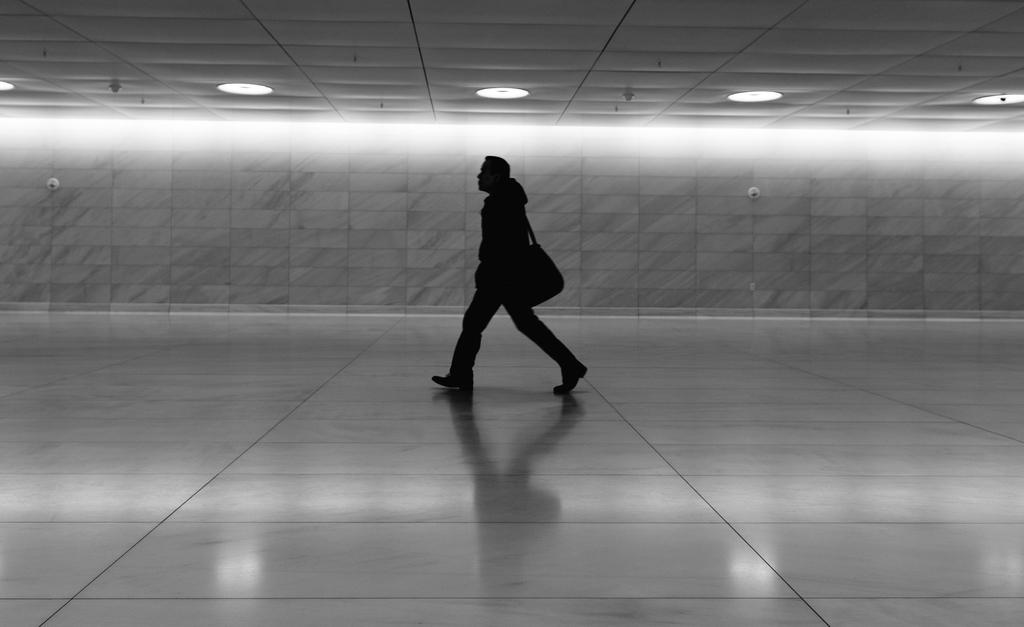Who is present in the image? There is a man in the image. What is the man doing in the image? The man is walking. What is the man carrying in the image? The man is wearing a bag. What can be seen in the background of the image? There is a wall in the background of the image. What is visible at the top of the image? There are lights visible at the top of the image. How many horses are present in the image? There are no horses present in the image; it features a man walking while wearing a bag. What type of pest can be seen in the image? There is no pest visible in the image. 